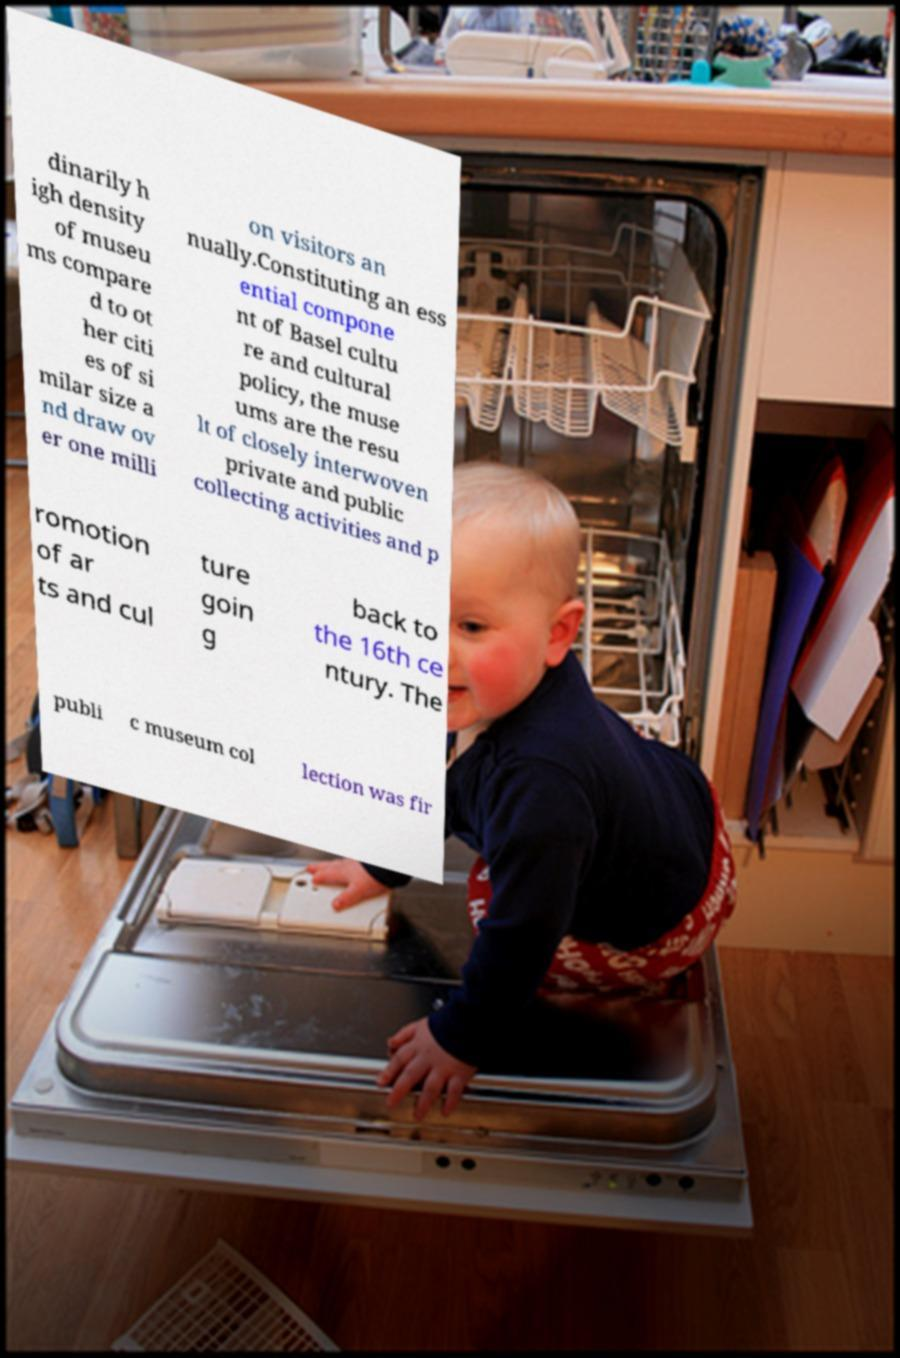Can you accurately transcribe the text from the provided image for me? dinarily h igh density of museu ms compare d to ot her citi es of si milar size a nd draw ov er one milli on visitors an nually.Constituting an ess ential compone nt of Basel cultu re and cultural policy, the muse ums are the resu lt of closely interwoven private and public collecting activities and p romotion of ar ts and cul ture goin g back to the 16th ce ntury. The publi c museum col lection was fir 